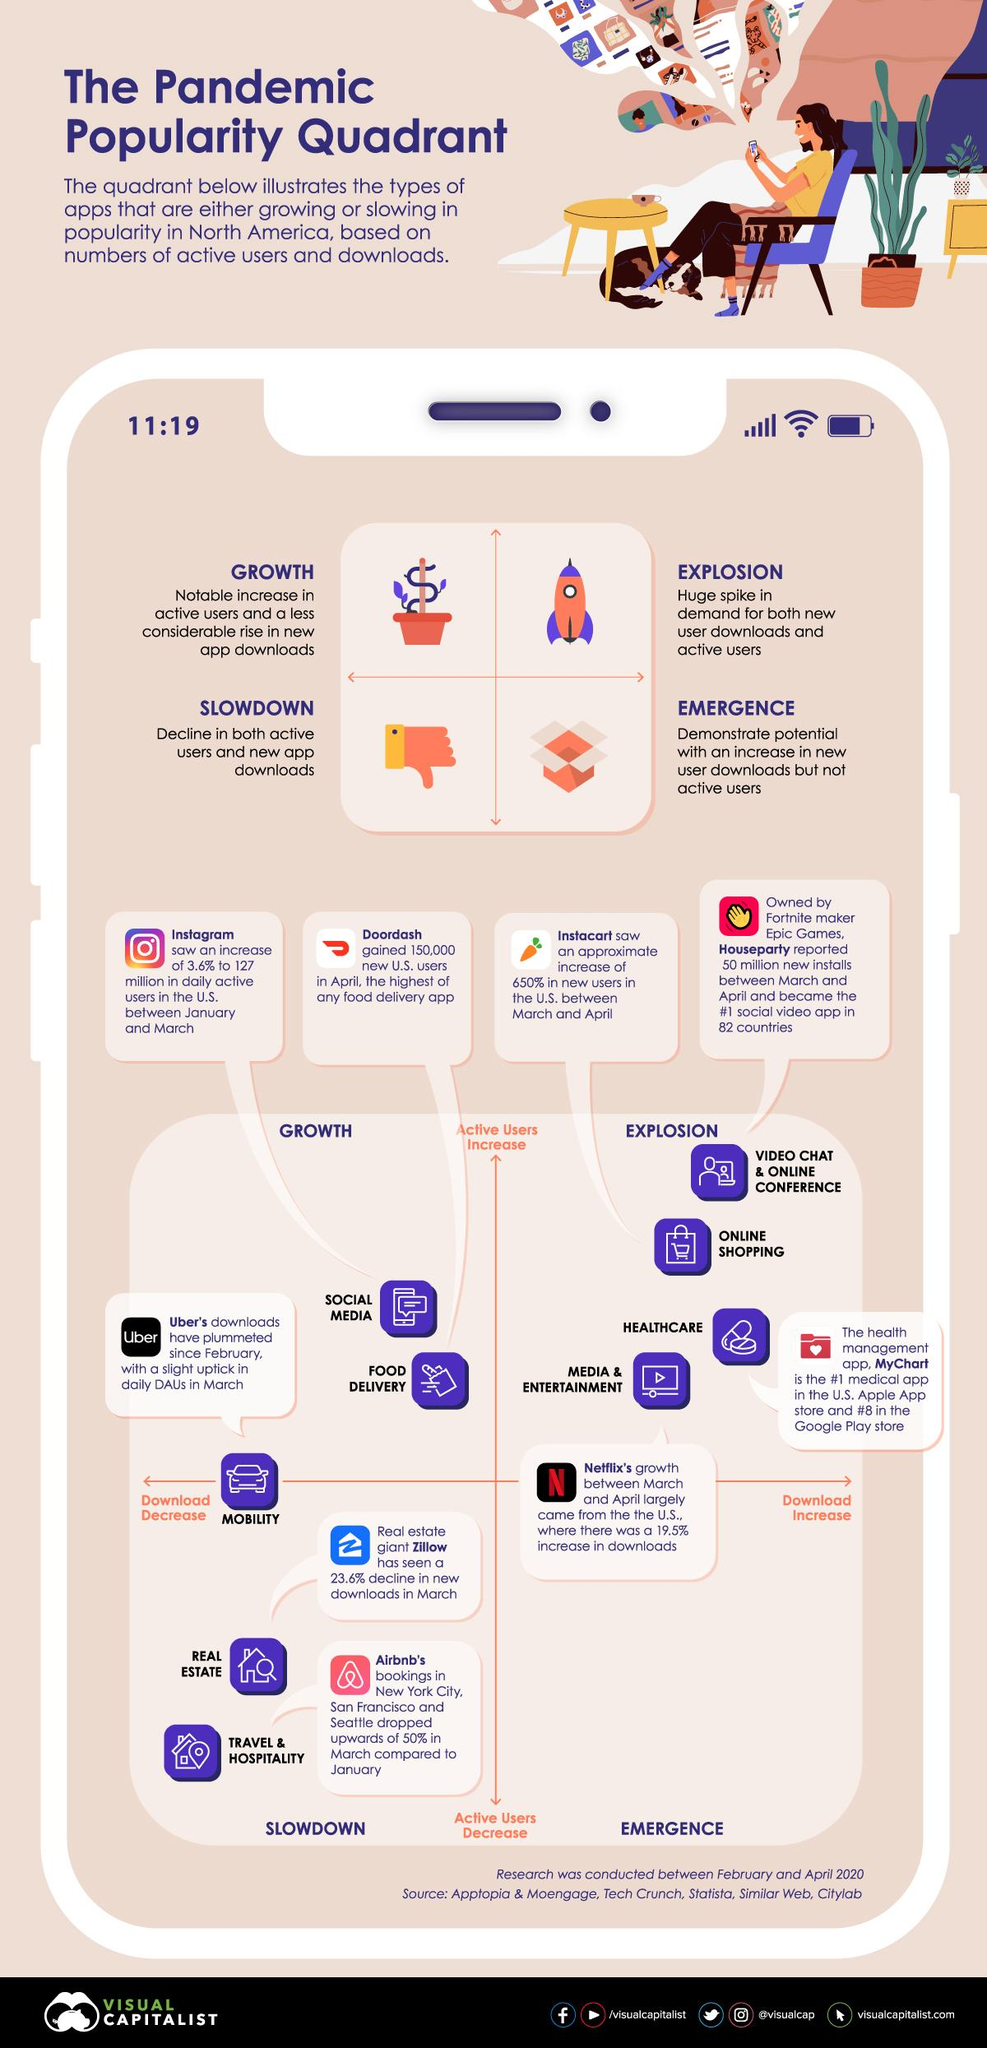Give some essential details in this illustration. Explosion Quadrant categorizes applications into four categories: Simple, Complex, Rugged, and High Security. The top right quadrant is commonly referred to as the Explosive category, which represents the highest level of creativity and innovation. The total number of unique categories of apps depicted in this infographic is 9. The healthcare application category has experienced the highest increase in downloads. The slowdown quadrant comprises applications that are categorized as real estate, travel and hospitality. 